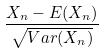<formula> <loc_0><loc_0><loc_500><loc_500>\frac { X _ { n } - E ( X _ { n } ) } { \sqrt { V a r ( X _ { n } ) } }</formula> 